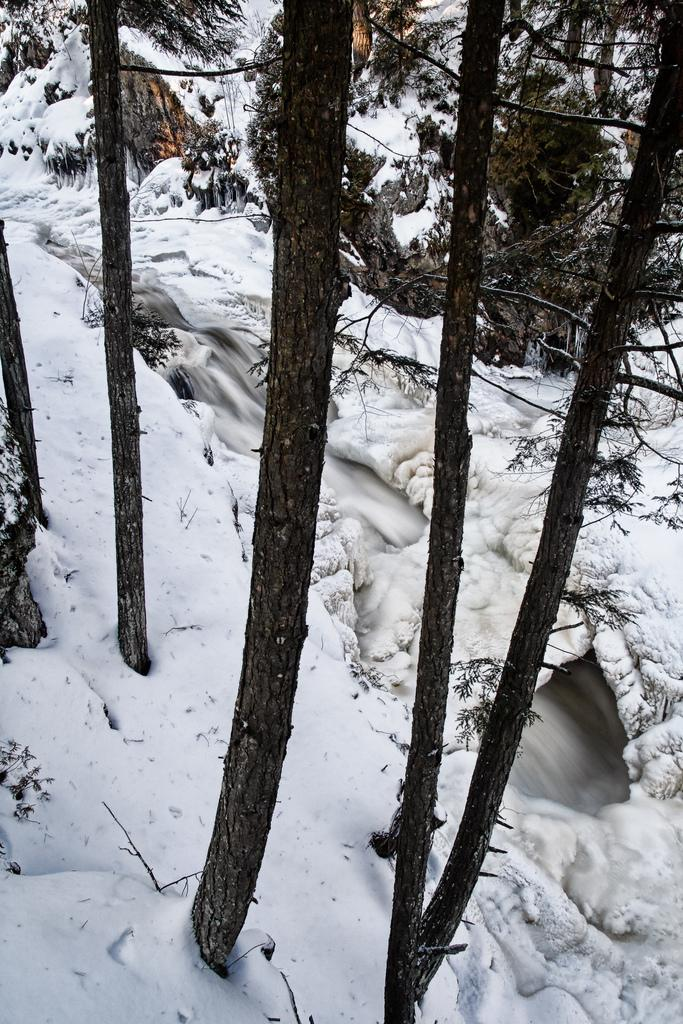What is the primary weather condition depicted in the image? There is snow in the picture. What type of natural elements can be seen in the image? There are trees in the picture. What type of drain is visible in the image? There is no drain present in the image; it features snow and trees. What type of conversation is happening between the trees in the image? Trees do not have the ability to talk or engage in conversation, so there is no such activity depicted in the image. 